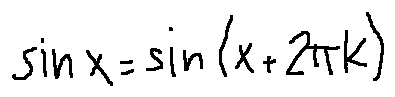<formula> <loc_0><loc_0><loc_500><loc_500>\sin x = \sin ( x + 2 \pi k )</formula> 